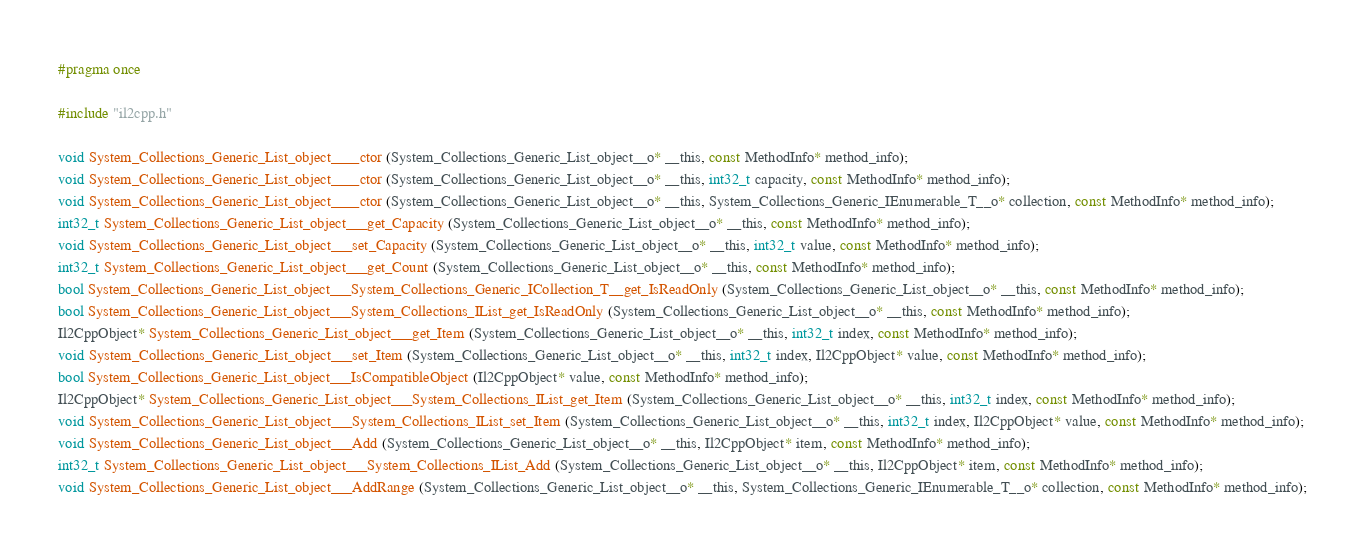<code> <loc_0><loc_0><loc_500><loc_500><_C_>#pragma once

#include "il2cpp.h"

void System_Collections_Generic_List_object____ctor (System_Collections_Generic_List_object__o* __this, const MethodInfo* method_info);
void System_Collections_Generic_List_object____ctor (System_Collections_Generic_List_object__o* __this, int32_t capacity, const MethodInfo* method_info);
void System_Collections_Generic_List_object____ctor (System_Collections_Generic_List_object__o* __this, System_Collections_Generic_IEnumerable_T__o* collection, const MethodInfo* method_info);
int32_t System_Collections_Generic_List_object___get_Capacity (System_Collections_Generic_List_object__o* __this, const MethodInfo* method_info);
void System_Collections_Generic_List_object___set_Capacity (System_Collections_Generic_List_object__o* __this, int32_t value, const MethodInfo* method_info);
int32_t System_Collections_Generic_List_object___get_Count (System_Collections_Generic_List_object__o* __this, const MethodInfo* method_info);
bool System_Collections_Generic_List_object___System_Collections_Generic_ICollection_T__get_IsReadOnly (System_Collections_Generic_List_object__o* __this, const MethodInfo* method_info);
bool System_Collections_Generic_List_object___System_Collections_IList_get_IsReadOnly (System_Collections_Generic_List_object__o* __this, const MethodInfo* method_info);
Il2CppObject* System_Collections_Generic_List_object___get_Item (System_Collections_Generic_List_object__o* __this, int32_t index, const MethodInfo* method_info);
void System_Collections_Generic_List_object___set_Item (System_Collections_Generic_List_object__o* __this, int32_t index, Il2CppObject* value, const MethodInfo* method_info);
bool System_Collections_Generic_List_object___IsCompatibleObject (Il2CppObject* value, const MethodInfo* method_info);
Il2CppObject* System_Collections_Generic_List_object___System_Collections_IList_get_Item (System_Collections_Generic_List_object__o* __this, int32_t index, const MethodInfo* method_info);
void System_Collections_Generic_List_object___System_Collections_IList_set_Item (System_Collections_Generic_List_object__o* __this, int32_t index, Il2CppObject* value, const MethodInfo* method_info);
void System_Collections_Generic_List_object___Add (System_Collections_Generic_List_object__o* __this, Il2CppObject* item, const MethodInfo* method_info);
int32_t System_Collections_Generic_List_object___System_Collections_IList_Add (System_Collections_Generic_List_object__o* __this, Il2CppObject* item, const MethodInfo* method_info);
void System_Collections_Generic_List_object___AddRange (System_Collections_Generic_List_object__o* __this, System_Collections_Generic_IEnumerable_T__o* collection, const MethodInfo* method_info);</code> 